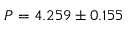Convert formula to latex. <formula><loc_0><loc_0><loc_500><loc_500>P = 4 . 2 5 9 \pm 0 . 1 5 5</formula> 